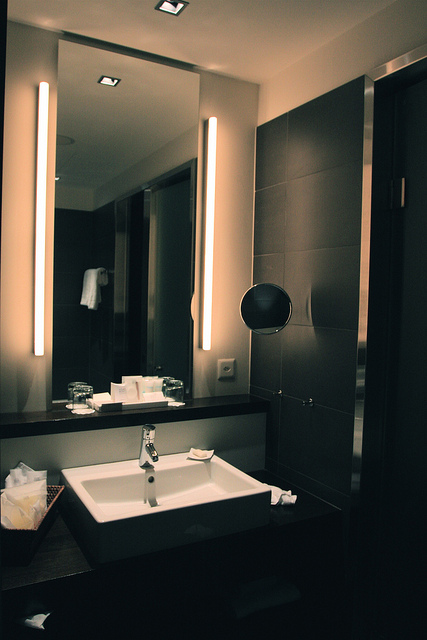Is there any basket in the image? If so, where is it located? Yes, there is a rectangular basket located at the bottom left corner of the image, likely used for storing towels or waste. 